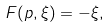<formula> <loc_0><loc_0><loc_500><loc_500>F ( p , \xi ) = - \xi ,</formula> 